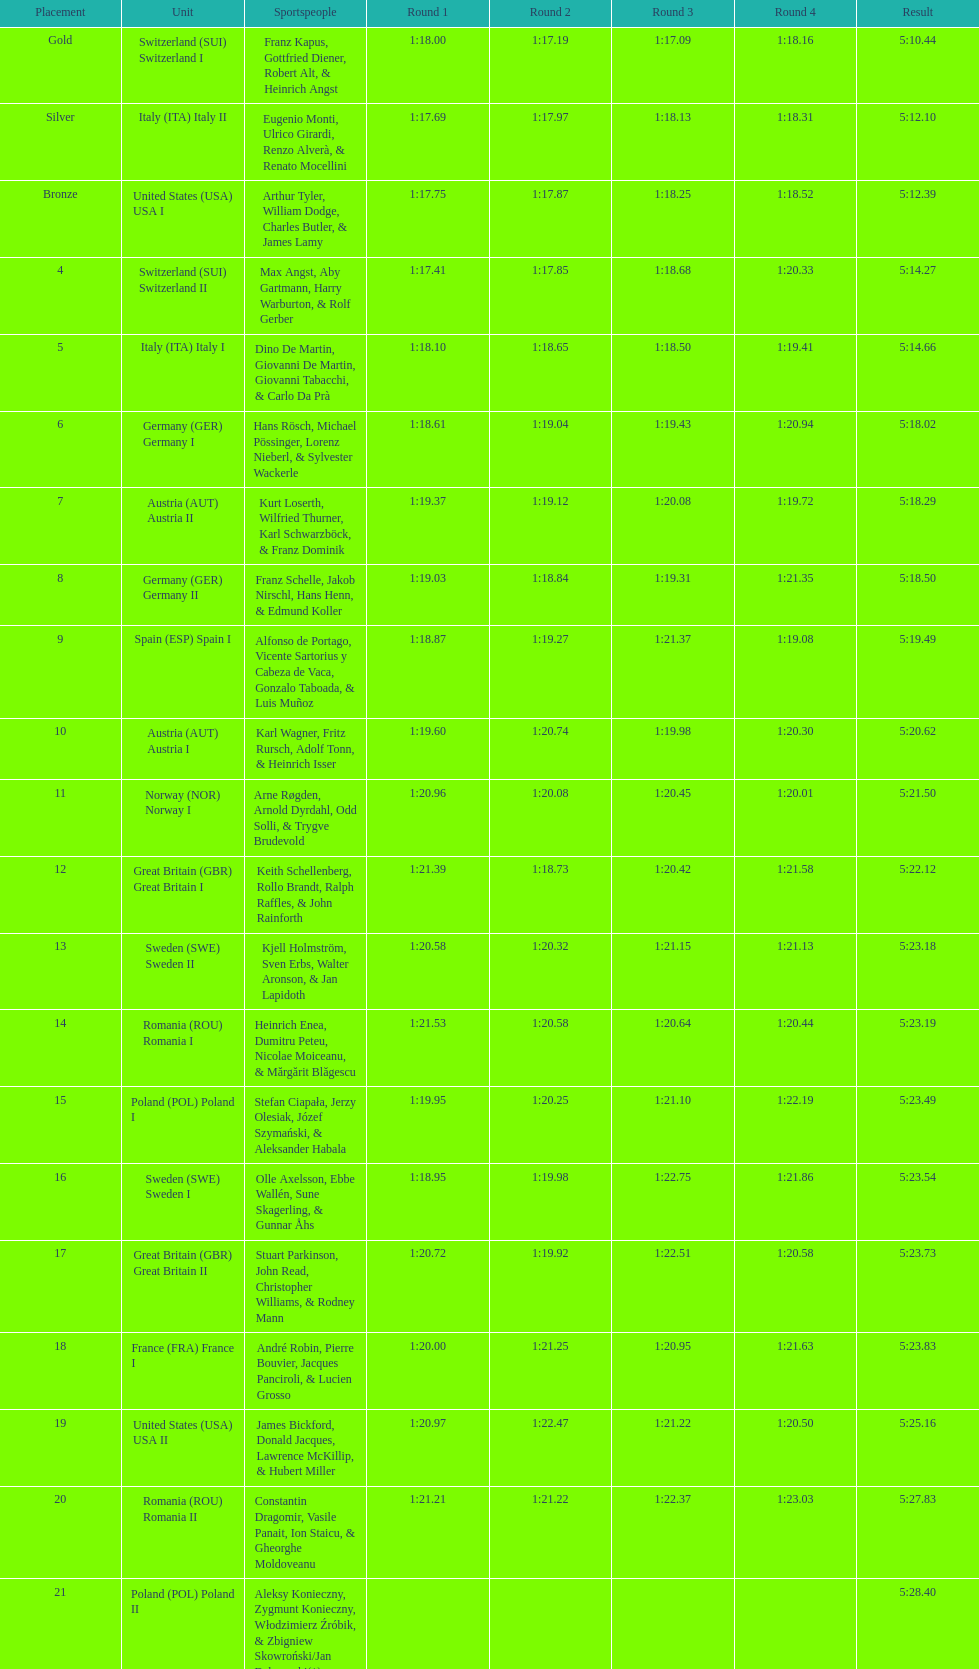What team came out on top? Switzerland. 